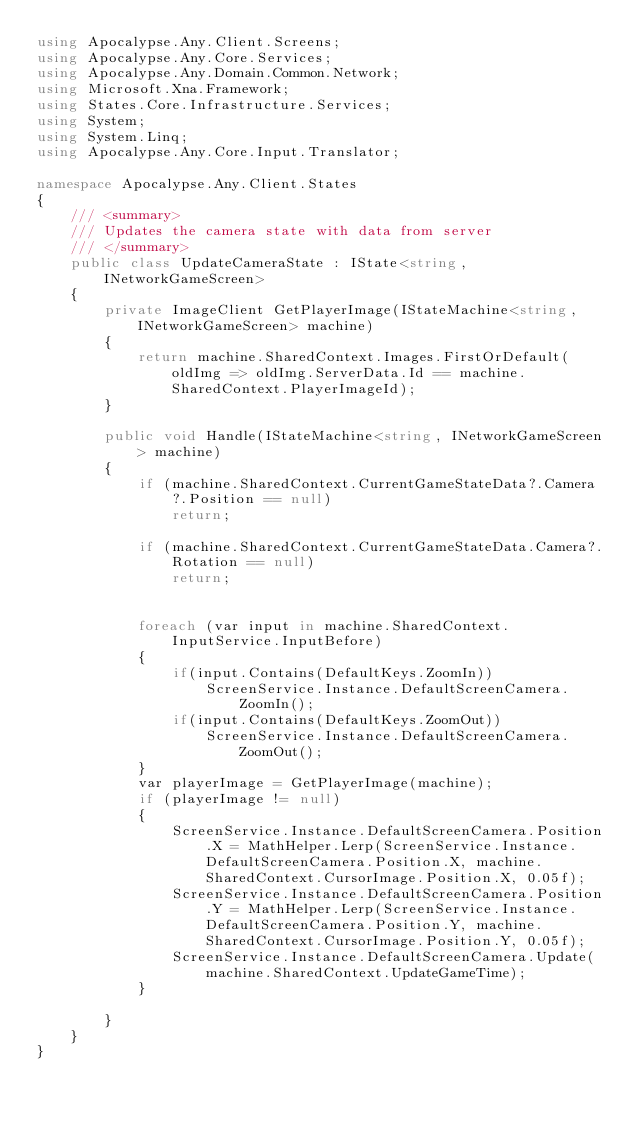Convert code to text. <code><loc_0><loc_0><loc_500><loc_500><_C#_>using Apocalypse.Any.Client.Screens;
using Apocalypse.Any.Core.Services;
using Apocalypse.Any.Domain.Common.Network;
using Microsoft.Xna.Framework;
using States.Core.Infrastructure.Services;
using System;
using System.Linq;
using Apocalypse.Any.Core.Input.Translator;

namespace Apocalypse.Any.Client.States
{
    /// <summary>
    /// Updates the camera state with data from server
    /// </summary>
    public class UpdateCameraState : IState<string, INetworkGameScreen>
    {
        private ImageClient GetPlayerImage(IStateMachine<string, INetworkGameScreen> machine)
        {
            return machine.SharedContext.Images.FirstOrDefault(oldImg => oldImg.ServerData.Id == machine.SharedContext.PlayerImageId);
        }

        public void Handle(IStateMachine<string, INetworkGameScreen> machine)
        {
            if (machine.SharedContext.CurrentGameStateData?.Camera?.Position == null)
                return;

            if (machine.SharedContext.CurrentGameStateData.Camera?.Rotation == null)
                return;

            
            foreach (var input in machine.SharedContext.InputService.InputBefore)
            {
                if(input.Contains(DefaultKeys.ZoomIn))
                    ScreenService.Instance.DefaultScreenCamera.ZoomIn();
                if(input.Contains(DefaultKeys.ZoomOut))
                    ScreenService.Instance.DefaultScreenCamera.ZoomOut();
            }
            var playerImage = GetPlayerImage(machine);
            if (playerImage != null)
            {
                ScreenService.Instance.DefaultScreenCamera.Position.X = MathHelper.Lerp(ScreenService.Instance.DefaultScreenCamera.Position.X, machine.SharedContext.CursorImage.Position.X, 0.05f);
                ScreenService.Instance.DefaultScreenCamera.Position.Y = MathHelper.Lerp(ScreenService.Instance.DefaultScreenCamera.Position.Y, machine.SharedContext.CursorImage.Position.Y, 0.05f);
                ScreenService.Instance.DefaultScreenCamera.Update(machine.SharedContext.UpdateGameTime);
            }

        }
    }
}</code> 